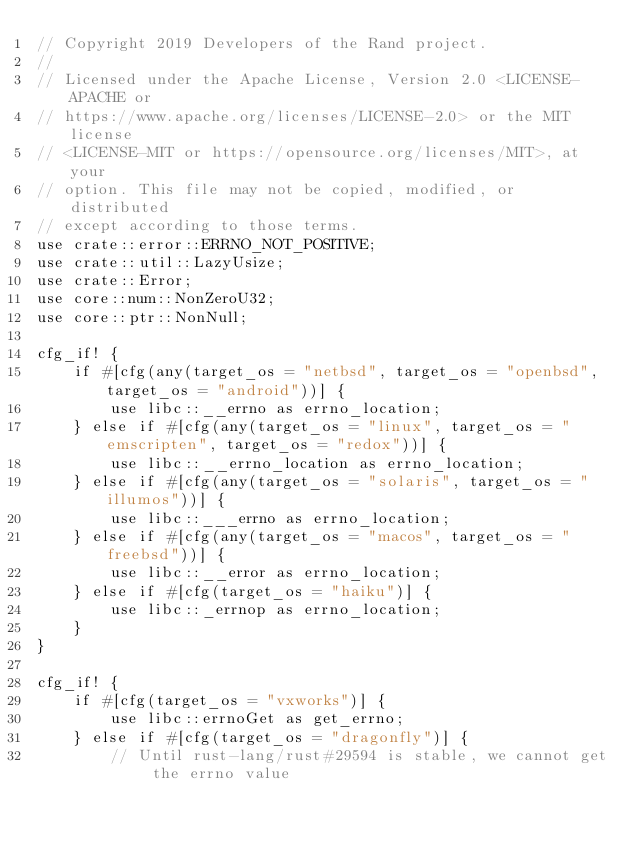<code> <loc_0><loc_0><loc_500><loc_500><_Rust_>// Copyright 2019 Developers of the Rand project.
//
// Licensed under the Apache License, Version 2.0 <LICENSE-APACHE or
// https://www.apache.org/licenses/LICENSE-2.0> or the MIT license
// <LICENSE-MIT or https://opensource.org/licenses/MIT>, at your
// option. This file may not be copied, modified, or distributed
// except according to those terms.
use crate::error::ERRNO_NOT_POSITIVE;
use crate::util::LazyUsize;
use crate::Error;
use core::num::NonZeroU32;
use core::ptr::NonNull;

cfg_if! {
    if #[cfg(any(target_os = "netbsd", target_os = "openbsd", target_os = "android"))] {
        use libc::__errno as errno_location;
    } else if #[cfg(any(target_os = "linux", target_os = "emscripten", target_os = "redox"))] {
        use libc::__errno_location as errno_location;
    } else if #[cfg(any(target_os = "solaris", target_os = "illumos"))] {
        use libc::___errno as errno_location;
    } else if #[cfg(any(target_os = "macos", target_os = "freebsd"))] {
        use libc::__error as errno_location;
    } else if #[cfg(target_os = "haiku")] {
        use libc::_errnop as errno_location;
    }
}

cfg_if! {
    if #[cfg(target_os = "vxworks")] {
        use libc::errnoGet as get_errno;
    } else if #[cfg(target_os = "dragonfly")] {
        // Until rust-lang/rust#29594 is stable, we cannot get the errno value</code> 